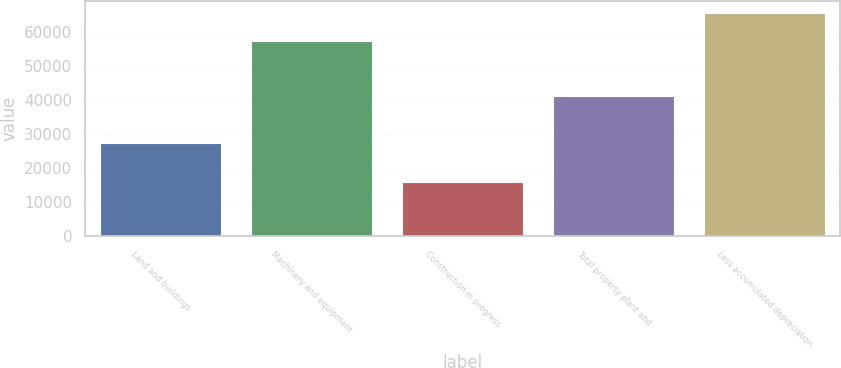Convert chart to OTSL. <chart><loc_0><loc_0><loc_500><loc_500><bar_chart><fcel>Land and buildings<fcel>Machinery and equipment<fcel>Construction in progress<fcel>Total property plant and<fcel>Less accumulated depreciation<nl><fcel>27391<fcel>57192<fcel>15812<fcel>41109<fcel>65650.3<nl></chart> 